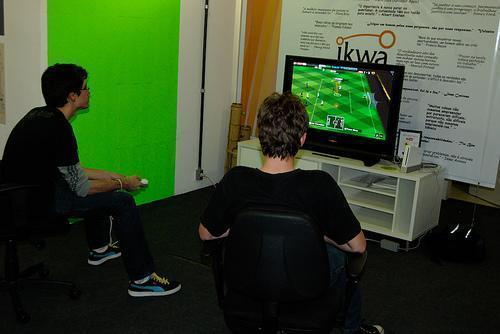What is the white thing the man is holding?
Select the correct answer and articulate reasoning with the following format: 'Answer: answer
Rationale: rationale.'
Options: Napkin, lighter, game remote, phone. Answer: game remote.
Rationale: They are playing a game 